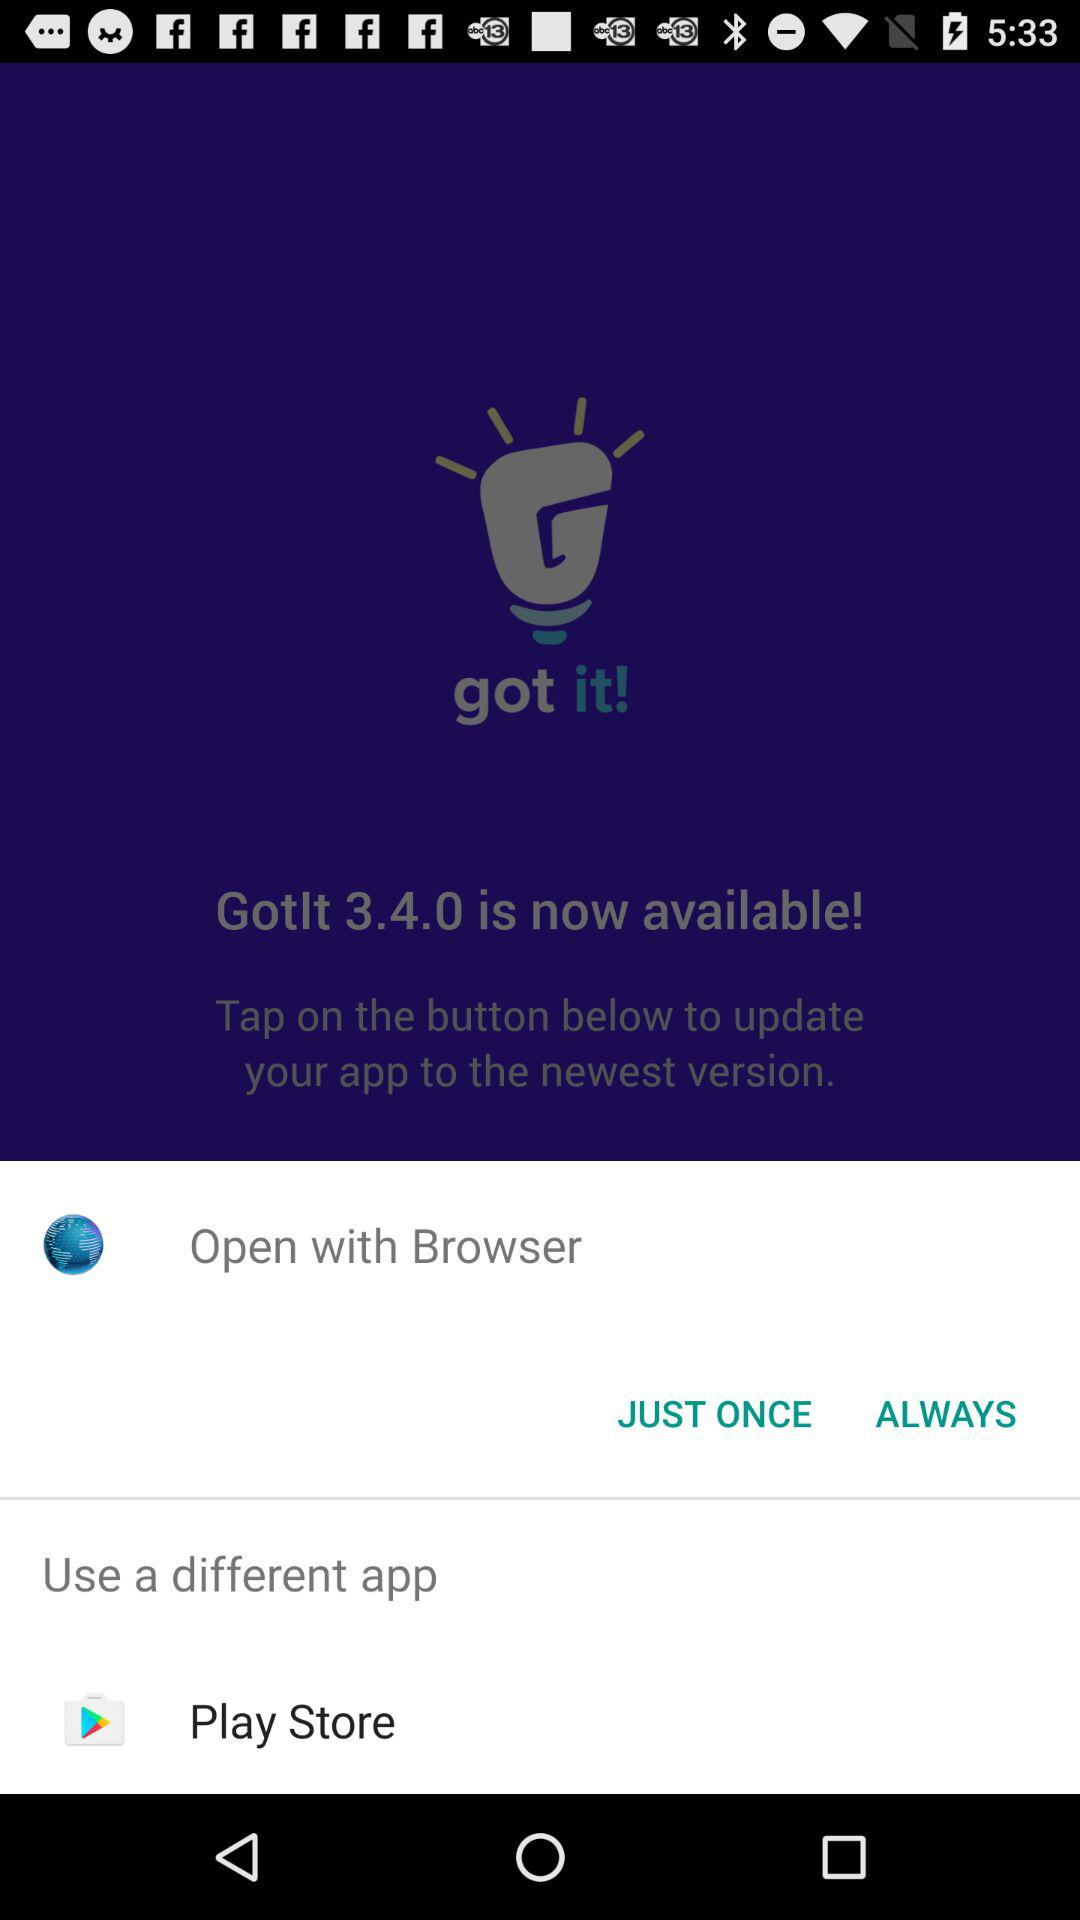Which options are given for opening? You can open it with "Browser" and "Play Store". 